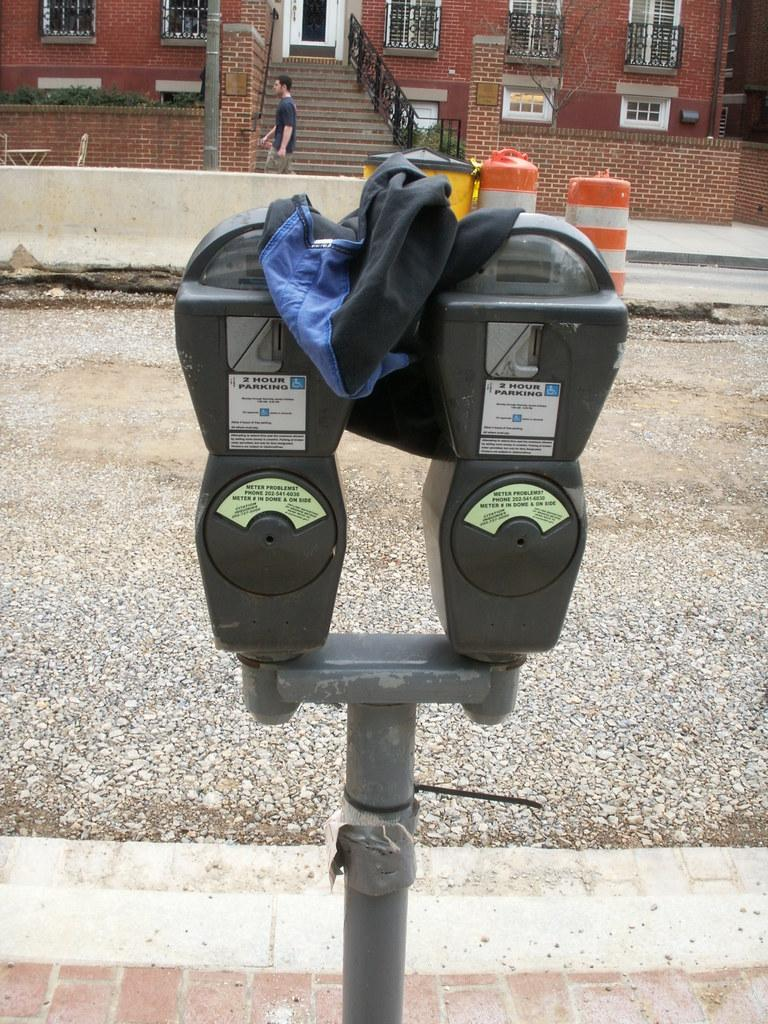<image>
Give a short and clear explanation of the subsequent image. a parking meter that has a white label on it that says '2 hour parking' 